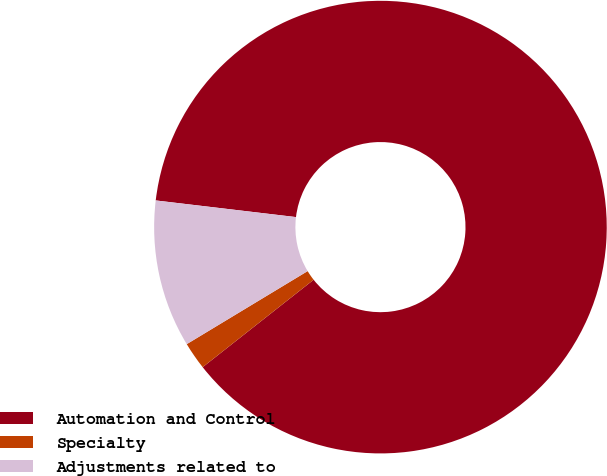Convert chart to OTSL. <chart><loc_0><loc_0><loc_500><loc_500><pie_chart><fcel>Automation and Control<fcel>Specialty<fcel>Adjustments related to<nl><fcel>87.5%<fcel>1.97%<fcel>10.53%<nl></chart> 